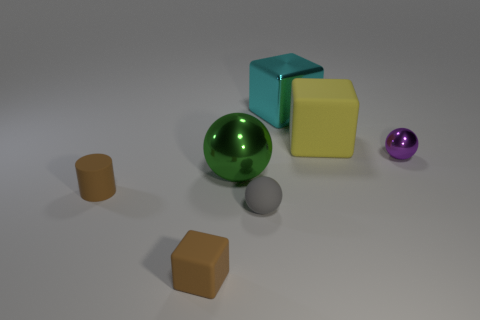What color is the matte thing that is behind the small shiny thing? Behind the small, shiny purple sphere, there is a large matte cube that is a shade of pale yellow or cream. 